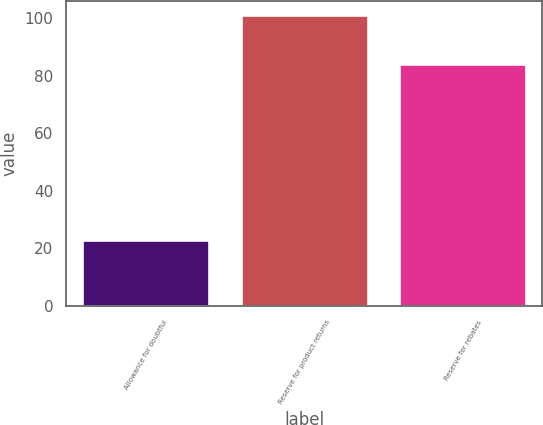<chart> <loc_0><loc_0><loc_500><loc_500><bar_chart><fcel>Allowance for doubtful<fcel>Reserve for product returns<fcel>Reserve for rebates<nl><fcel>23<fcel>101<fcel>84<nl></chart> 